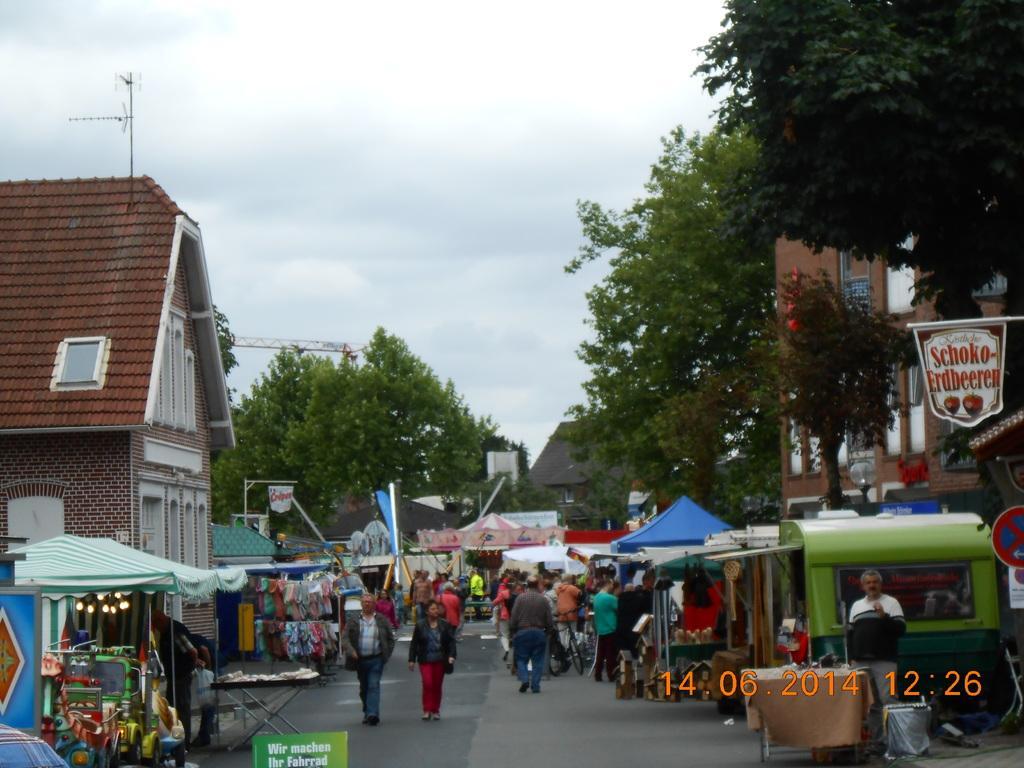Can you describe this image briefly? In this image I can see stalls and people are present. There are trees and buildings at the back. There is a sign board and the date and time is mentioned at the bottom. 